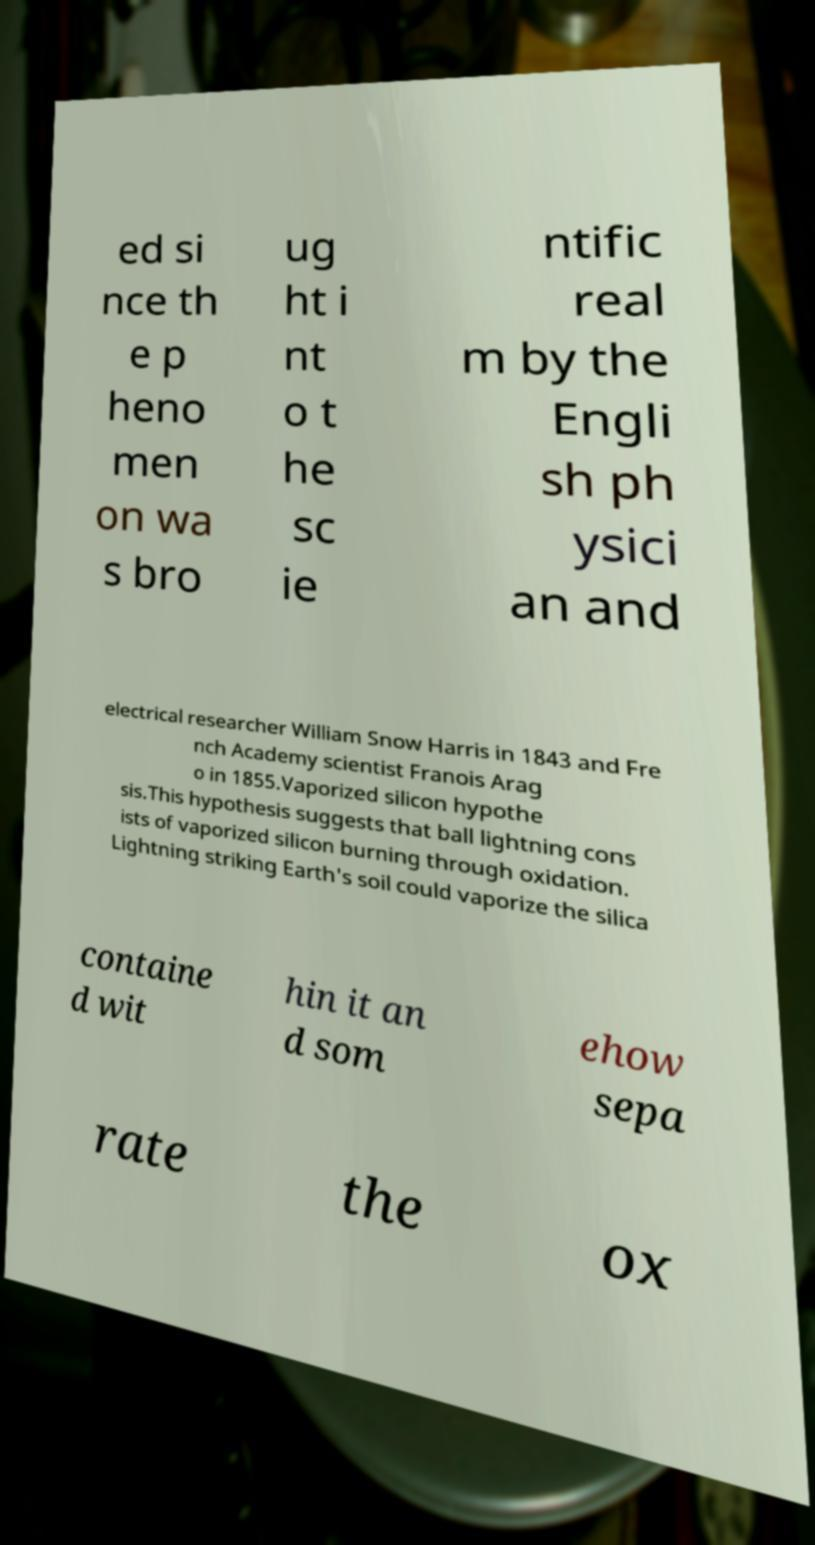Please identify and transcribe the text found in this image. ed si nce th e p heno men on wa s bro ug ht i nt o t he sc ie ntific real m by the Engli sh ph ysici an and electrical researcher William Snow Harris in 1843 and Fre nch Academy scientist Franois Arag o in 1855.Vaporized silicon hypothe sis.This hypothesis suggests that ball lightning cons ists of vaporized silicon burning through oxidation. Lightning striking Earth's soil could vaporize the silica containe d wit hin it an d som ehow sepa rate the ox 